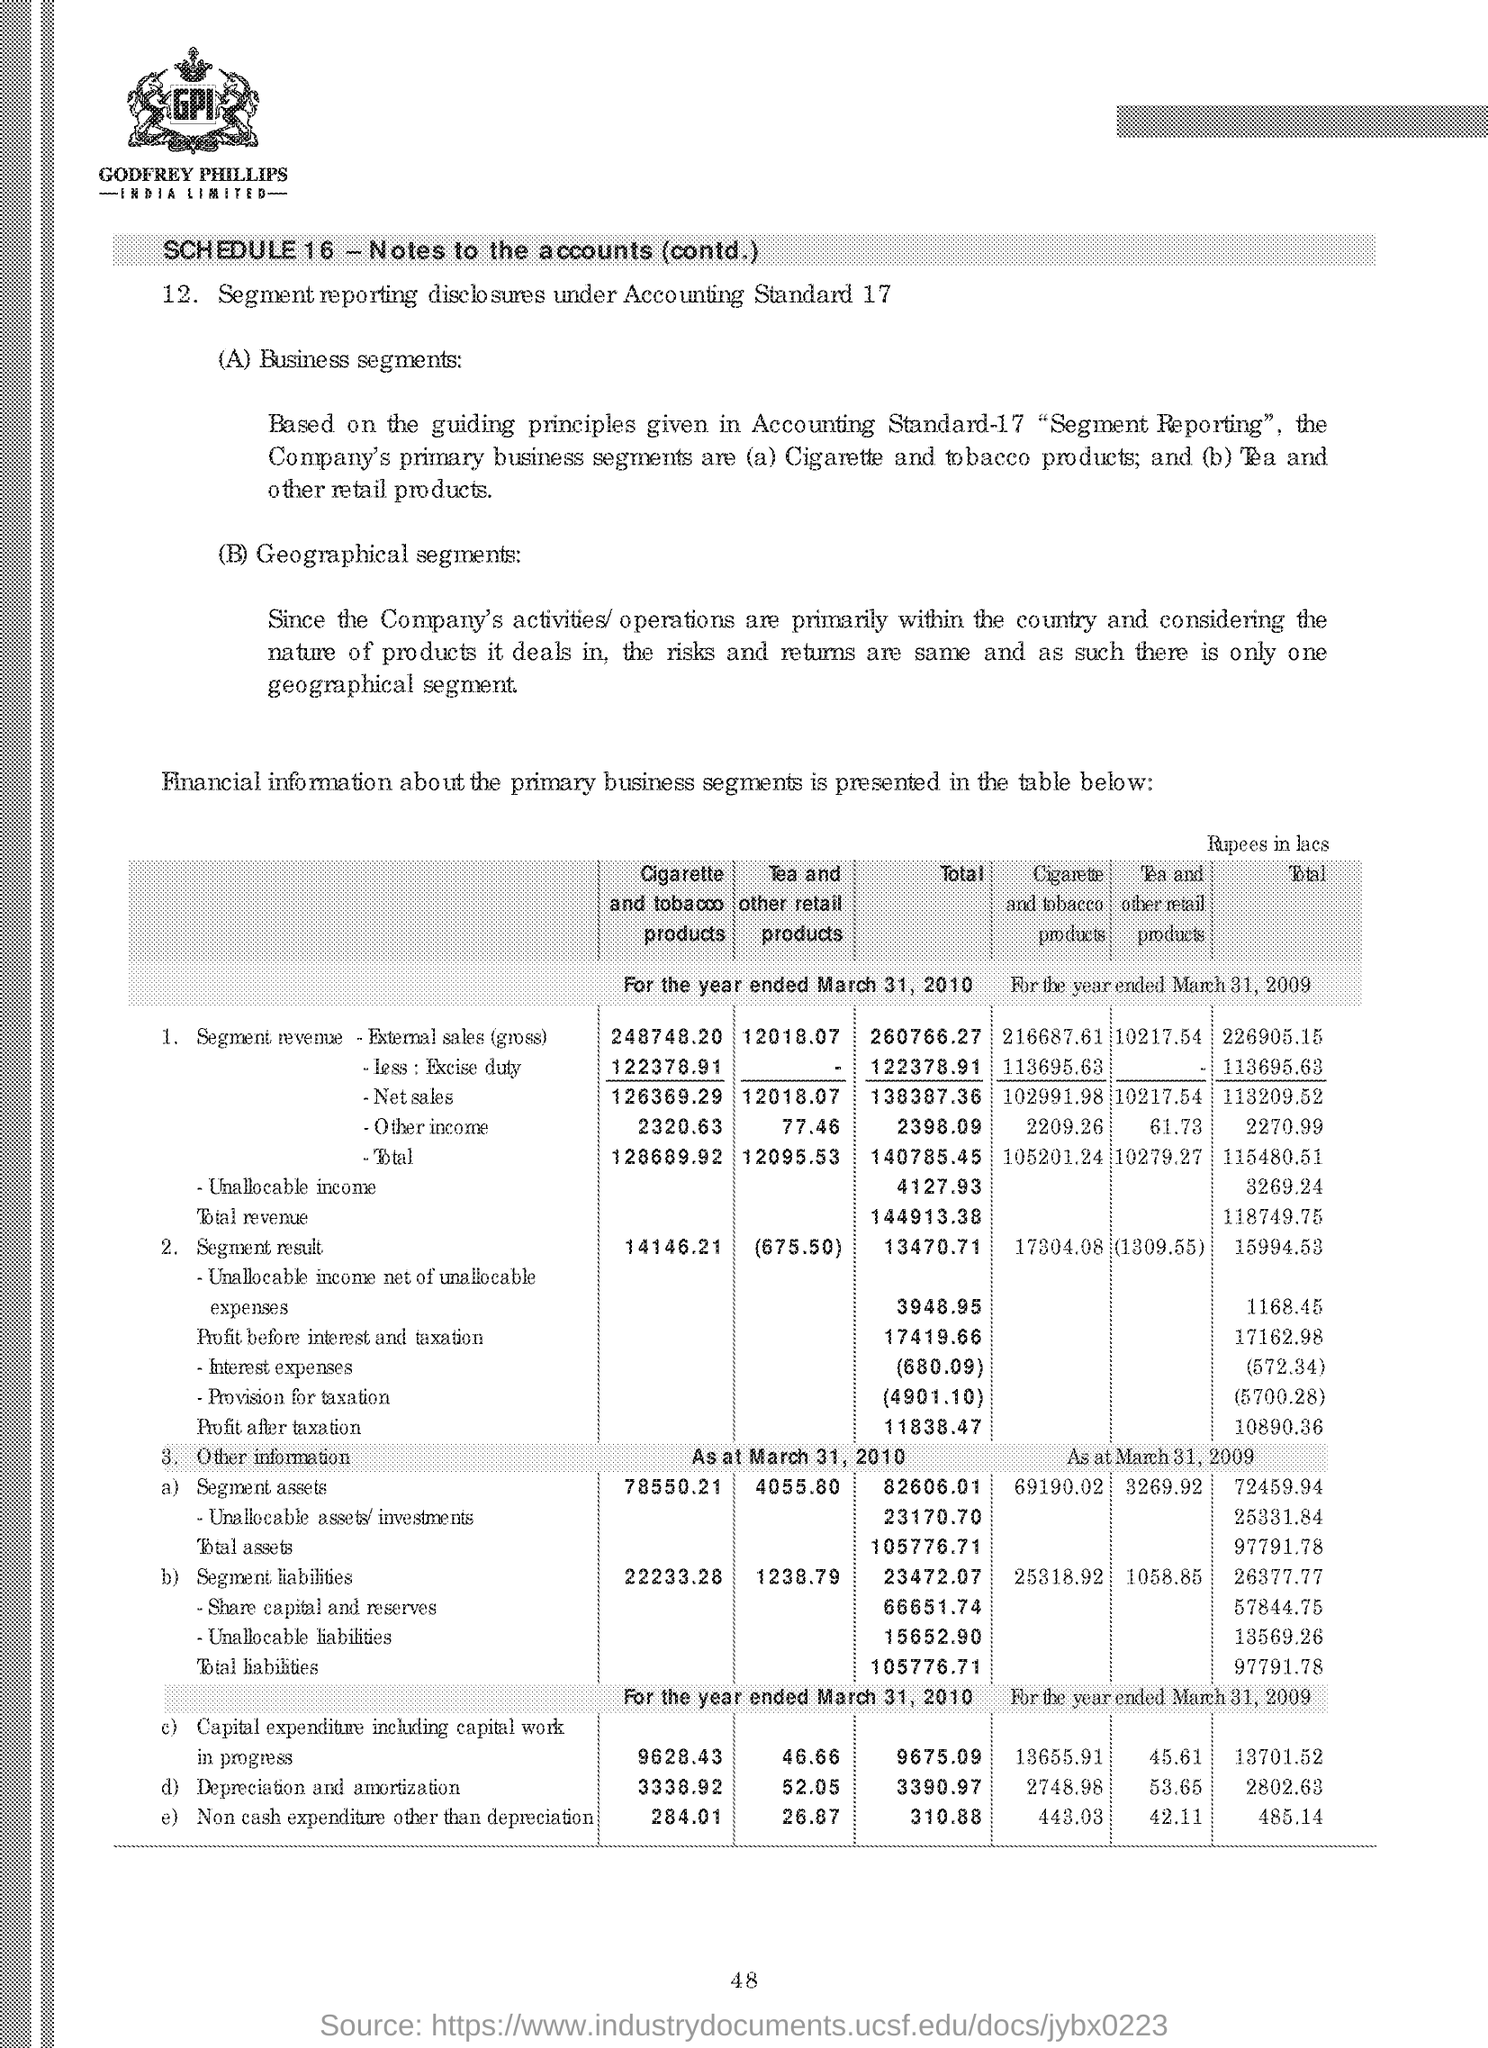What is the segment revenue external sales (gross)for the cigarette and tobacco products for the year ended march 31, 2010
Your response must be concise. 248748.20. What is the total revenue for the segment revenue for the year ended march 31,2010
Offer a terse response. 144913.38. Segment reporting disclosures under which accounting standard ?
Offer a very short reply. Accounting Standard-17. What is the total non cash expenditure other than depreciation for the year ended march 31,2010
Make the answer very short. 310.88. What is the total non cash expenditure other than depreciation for the year ended march 31,2009
Ensure brevity in your answer.  485.14. 